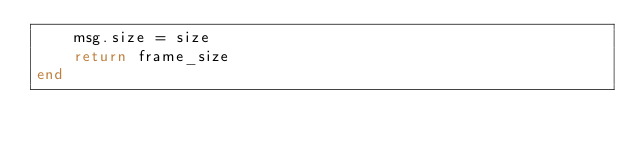Convert code to text. <code><loc_0><loc_0><loc_500><loc_500><_Lua_>	msg.size = size
	return frame_size
end
</code> 